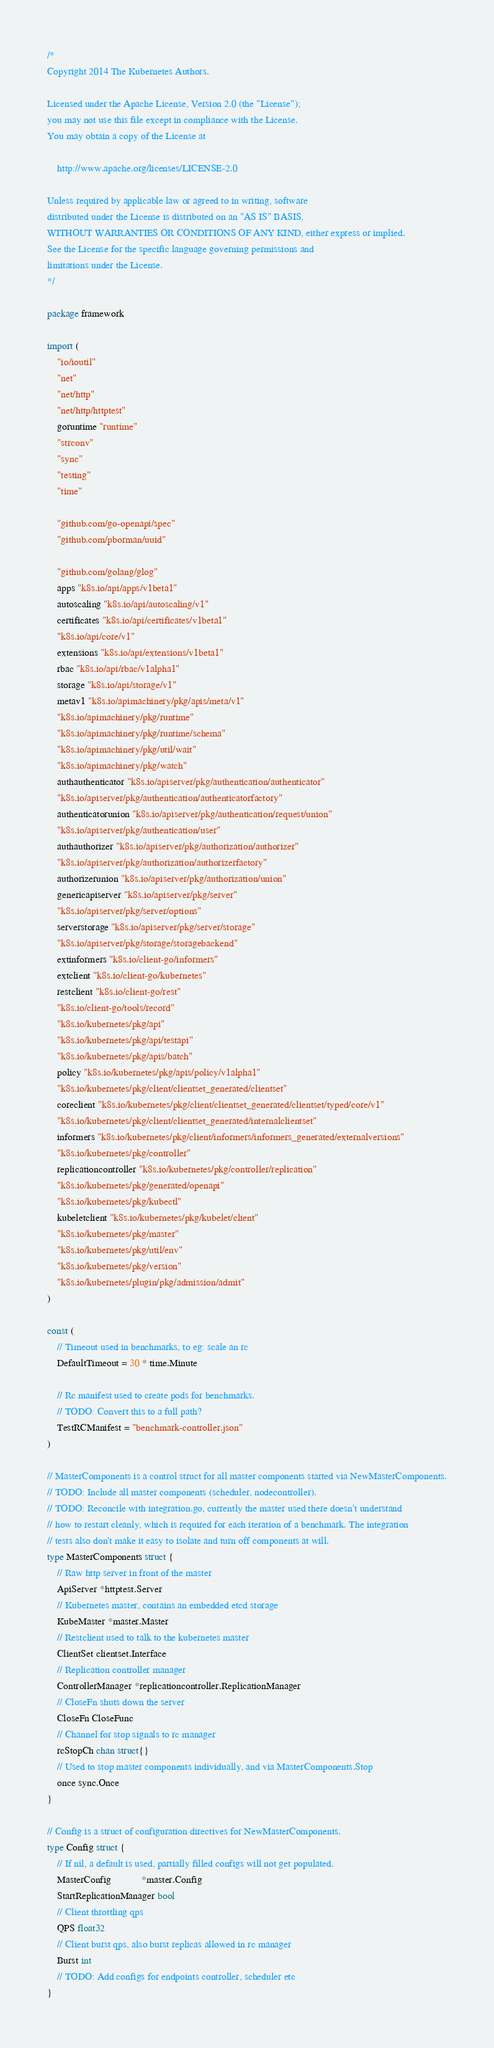Convert code to text. <code><loc_0><loc_0><loc_500><loc_500><_Go_>/*
Copyright 2014 The Kubernetes Authors.

Licensed under the Apache License, Version 2.0 (the "License");
you may not use this file except in compliance with the License.
You may obtain a copy of the License at

    http://www.apache.org/licenses/LICENSE-2.0

Unless required by applicable law or agreed to in writing, software
distributed under the License is distributed on an "AS IS" BASIS,
WITHOUT WARRANTIES OR CONDITIONS OF ANY KIND, either express or implied.
See the License for the specific language governing permissions and
limitations under the License.
*/

package framework

import (
	"io/ioutil"
	"net"
	"net/http"
	"net/http/httptest"
	goruntime "runtime"
	"strconv"
	"sync"
	"testing"
	"time"

	"github.com/go-openapi/spec"
	"github.com/pborman/uuid"

	"github.com/golang/glog"
	apps "k8s.io/api/apps/v1beta1"
	autoscaling "k8s.io/api/autoscaling/v1"
	certificates "k8s.io/api/certificates/v1beta1"
	"k8s.io/api/core/v1"
	extensions "k8s.io/api/extensions/v1beta1"
	rbac "k8s.io/api/rbac/v1alpha1"
	storage "k8s.io/api/storage/v1"
	metav1 "k8s.io/apimachinery/pkg/apis/meta/v1"
	"k8s.io/apimachinery/pkg/runtime"
	"k8s.io/apimachinery/pkg/runtime/schema"
	"k8s.io/apimachinery/pkg/util/wait"
	"k8s.io/apimachinery/pkg/watch"
	authauthenticator "k8s.io/apiserver/pkg/authentication/authenticator"
	"k8s.io/apiserver/pkg/authentication/authenticatorfactory"
	authenticatorunion "k8s.io/apiserver/pkg/authentication/request/union"
	"k8s.io/apiserver/pkg/authentication/user"
	authauthorizer "k8s.io/apiserver/pkg/authorization/authorizer"
	"k8s.io/apiserver/pkg/authorization/authorizerfactory"
	authorizerunion "k8s.io/apiserver/pkg/authorization/union"
	genericapiserver "k8s.io/apiserver/pkg/server"
	"k8s.io/apiserver/pkg/server/options"
	serverstorage "k8s.io/apiserver/pkg/server/storage"
	"k8s.io/apiserver/pkg/storage/storagebackend"
	extinformers "k8s.io/client-go/informers"
	extclient "k8s.io/client-go/kubernetes"
	restclient "k8s.io/client-go/rest"
	"k8s.io/client-go/tools/record"
	"k8s.io/kubernetes/pkg/api"
	"k8s.io/kubernetes/pkg/api/testapi"
	"k8s.io/kubernetes/pkg/apis/batch"
	policy "k8s.io/kubernetes/pkg/apis/policy/v1alpha1"
	"k8s.io/kubernetes/pkg/client/clientset_generated/clientset"
	coreclient "k8s.io/kubernetes/pkg/client/clientset_generated/clientset/typed/core/v1"
	"k8s.io/kubernetes/pkg/client/clientset_generated/internalclientset"
	informers "k8s.io/kubernetes/pkg/client/informers/informers_generated/externalversions"
	"k8s.io/kubernetes/pkg/controller"
	replicationcontroller "k8s.io/kubernetes/pkg/controller/replication"
	"k8s.io/kubernetes/pkg/generated/openapi"
	"k8s.io/kubernetes/pkg/kubectl"
	kubeletclient "k8s.io/kubernetes/pkg/kubelet/client"
	"k8s.io/kubernetes/pkg/master"
	"k8s.io/kubernetes/pkg/util/env"
	"k8s.io/kubernetes/pkg/version"
	"k8s.io/kubernetes/plugin/pkg/admission/admit"
)

const (
	// Timeout used in benchmarks, to eg: scale an rc
	DefaultTimeout = 30 * time.Minute

	// Rc manifest used to create pods for benchmarks.
	// TODO: Convert this to a full path?
	TestRCManifest = "benchmark-controller.json"
)

// MasterComponents is a control struct for all master components started via NewMasterComponents.
// TODO: Include all master components (scheduler, nodecontroller).
// TODO: Reconcile with integration.go, currently the master used there doesn't understand
// how to restart cleanly, which is required for each iteration of a benchmark. The integration
// tests also don't make it easy to isolate and turn off components at will.
type MasterComponents struct {
	// Raw http server in front of the master
	ApiServer *httptest.Server
	// Kubernetes master, contains an embedded etcd storage
	KubeMaster *master.Master
	// Restclient used to talk to the kubernetes master
	ClientSet clientset.Interface
	// Replication controller manager
	ControllerManager *replicationcontroller.ReplicationManager
	// CloseFn shuts down the server
	CloseFn CloseFunc
	// Channel for stop signals to rc manager
	rcStopCh chan struct{}
	// Used to stop master components individually, and via MasterComponents.Stop
	once sync.Once
}

// Config is a struct of configuration directives for NewMasterComponents.
type Config struct {
	// If nil, a default is used, partially filled configs will not get populated.
	MasterConfig            *master.Config
	StartReplicationManager bool
	// Client throttling qps
	QPS float32
	// Client burst qps, also burst replicas allowed in rc manager
	Burst int
	// TODO: Add configs for endpoints controller, scheduler etc
}
</code> 